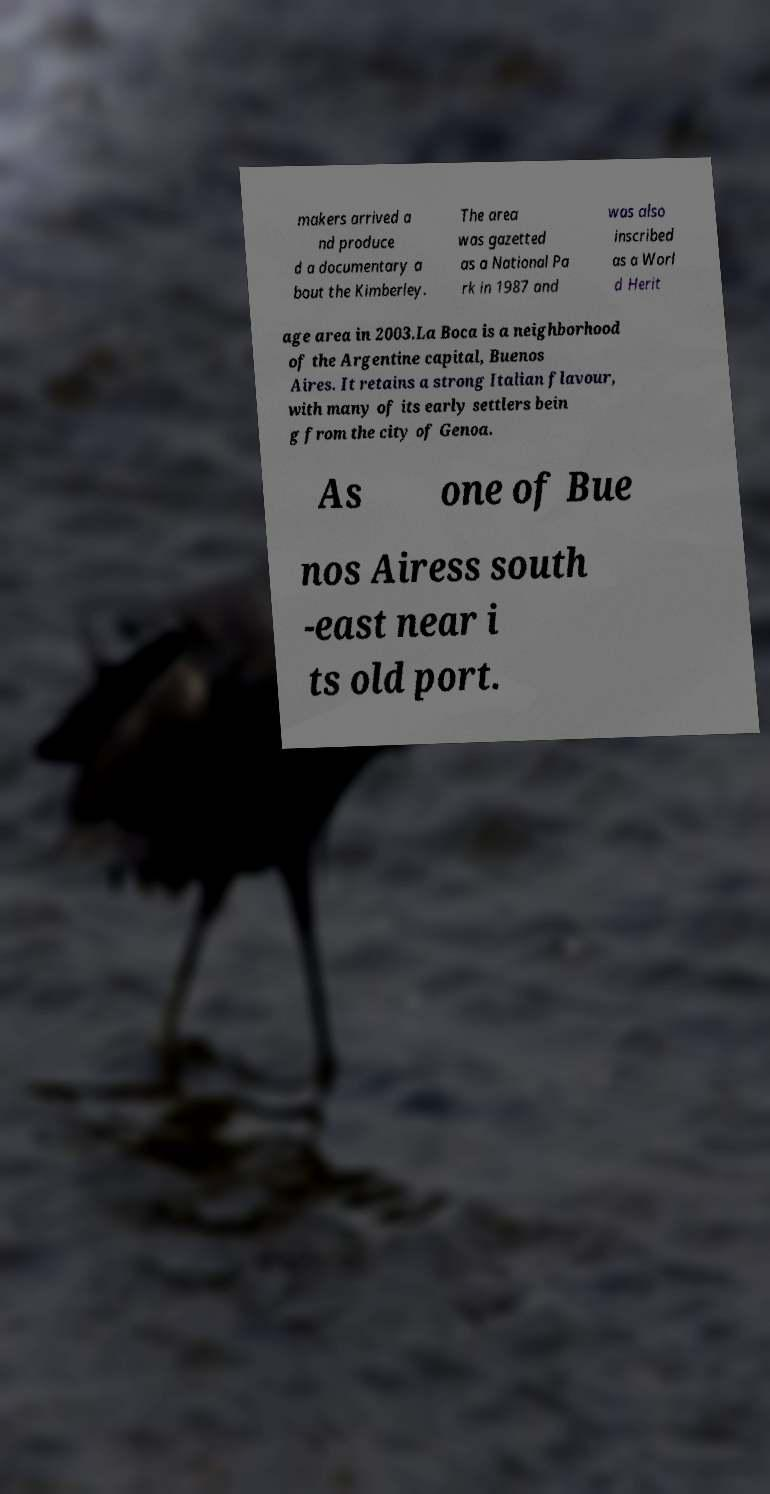Could you extract and type out the text from this image? makers arrived a nd produce d a documentary a bout the Kimberley. The area was gazetted as a National Pa rk in 1987 and was also inscribed as a Worl d Herit age area in 2003.La Boca is a neighborhood of the Argentine capital, Buenos Aires. It retains a strong Italian flavour, with many of its early settlers bein g from the city of Genoa. As one of Bue nos Airess south -east near i ts old port. 